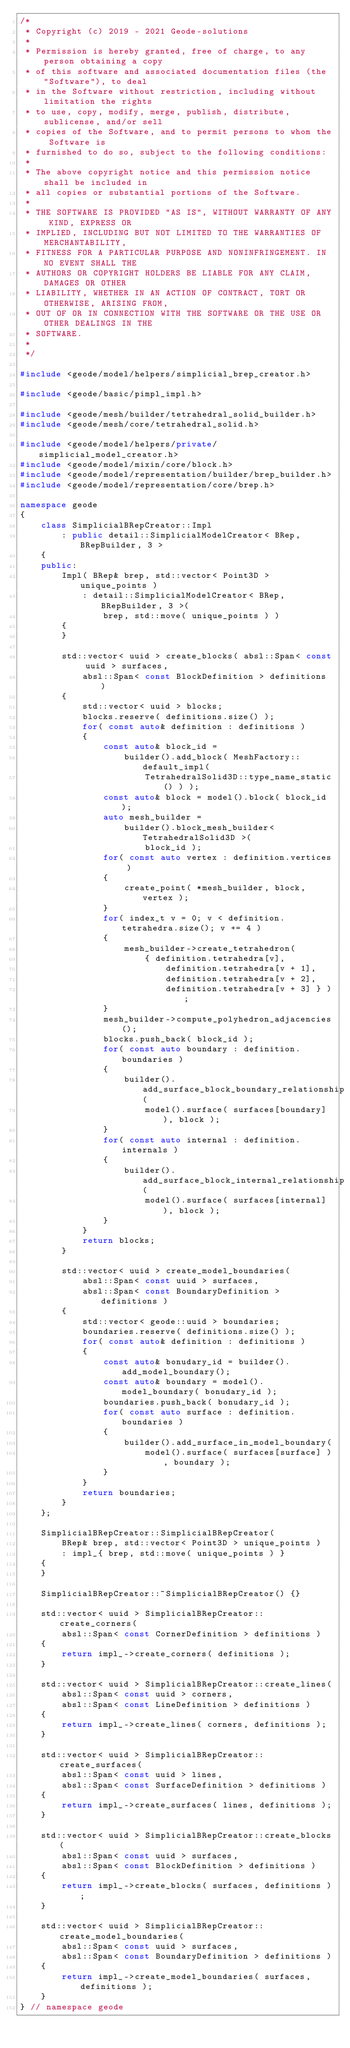<code> <loc_0><loc_0><loc_500><loc_500><_C++_>/*
 * Copyright (c) 2019 - 2021 Geode-solutions
 *
 * Permission is hereby granted, free of charge, to any person obtaining a copy
 * of this software and associated documentation files (the "Software"), to deal
 * in the Software without restriction, including without limitation the rights
 * to use, copy, modify, merge, publish, distribute, sublicense, and/or sell
 * copies of the Software, and to permit persons to whom the Software is
 * furnished to do so, subject to the following conditions:
 *
 * The above copyright notice and this permission notice shall be included in
 * all copies or substantial portions of the Software.
 *
 * THE SOFTWARE IS PROVIDED "AS IS", WITHOUT WARRANTY OF ANY KIND, EXPRESS OR
 * IMPLIED, INCLUDING BUT NOT LIMITED TO THE WARRANTIES OF MERCHANTABILITY,
 * FITNESS FOR A PARTICULAR PURPOSE AND NONINFRINGEMENT. IN NO EVENT SHALL THE
 * AUTHORS OR COPYRIGHT HOLDERS BE LIABLE FOR ANY CLAIM, DAMAGES OR OTHER
 * LIABILITY, WHETHER IN AN ACTION OF CONTRACT, TORT OR OTHERWISE, ARISING FROM,
 * OUT OF OR IN CONNECTION WITH THE SOFTWARE OR THE USE OR OTHER DEALINGS IN THE
 * SOFTWARE.
 *
 */

#include <geode/model/helpers/simplicial_brep_creator.h>

#include <geode/basic/pimpl_impl.h>

#include <geode/mesh/builder/tetrahedral_solid_builder.h>
#include <geode/mesh/core/tetrahedral_solid.h>

#include <geode/model/helpers/private/simplicial_model_creator.h>
#include <geode/model/mixin/core/block.h>
#include <geode/model/representation/builder/brep_builder.h>
#include <geode/model/representation/core/brep.h>

namespace geode
{
    class SimplicialBRepCreator::Impl
        : public detail::SimplicialModelCreator< BRep, BRepBuilder, 3 >
    {
    public:
        Impl( BRep& brep, std::vector< Point3D > unique_points )
            : detail::SimplicialModelCreator< BRep, BRepBuilder, 3 >(
                brep, std::move( unique_points ) )
        {
        }

        std::vector< uuid > create_blocks( absl::Span< const uuid > surfaces,
            absl::Span< const BlockDefinition > definitions )
        {
            std::vector< uuid > blocks;
            blocks.reserve( definitions.size() );
            for( const auto& definition : definitions )
            {
                const auto& block_id =
                    builder().add_block( MeshFactory::default_impl(
                        TetrahedralSolid3D::type_name_static() ) );
                const auto& block = model().block( block_id );
                auto mesh_builder =
                    builder().block_mesh_builder< TetrahedralSolid3D >(
                        block_id );
                for( const auto vertex : definition.vertices )
                {
                    create_point( *mesh_builder, block, vertex );
                }
                for( index_t v = 0; v < definition.tetrahedra.size(); v += 4 )
                {
                    mesh_builder->create_tetrahedron(
                        { definition.tetrahedra[v],
                            definition.tetrahedra[v + 1],
                            definition.tetrahedra[v + 2],
                            definition.tetrahedra[v + 3] } );
                }
                mesh_builder->compute_polyhedron_adjacencies();
                blocks.push_back( block_id );
                for( const auto boundary : definition.boundaries )
                {
                    builder().add_surface_block_boundary_relationship(
                        model().surface( surfaces[boundary] ), block );
                }
                for( const auto internal : definition.internals )
                {
                    builder().add_surface_block_internal_relationship(
                        model().surface( surfaces[internal] ), block );
                }
            }
            return blocks;
        }

        std::vector< uuid > create_model_boundaries(
            absl::Span< const uuid > surfaces,
            absl::Span< const BoundaryDefinition > definitions )
        {
            std::vector< geode::uuid > boundaries;
            boundaries.reserve( definitions.size() );
            for( const auto& definition : definitions )
            {
                const auto& bonudary_id = builder().add_model_boundary();
                const auto& boundary = model().model_boundary( bonudary_id );
                boundaries.push_back( bonudary_id );
                for( const auto surface : definition.boundaries )
                {
                    builder().add_surface_in_model_boundary(
                        model().surface( surfaces[surface] ), boundary );
                }
            }
            return boundaries;
        }
    };

    SimplicialBRepCreator::SimplicialBRepCreator(
        BRep& brep, std::vector< Point3D > unique_points )
        : impl_{ brep, std::move( unique_points ) }
    {
    }

    SimplicialBRepCreator::~SimplicialBRepCreator() {}

    std::vector< uuid > SimplicialBRepCreator::create_corners(
        absl::Span< const CornerDefinition > definitions )
    {
        return impl_->create_corners( definitions );
    }

    std::vector< uuid > SimplicialBRepCreator::create_lines(
        absl::Span< const uuid > corners,
        absl::Span< const LineDefinition > definitions )
    {
        return impl_->create_lines( corners, definitions );
    }

    std::vector< uuid > SimplicialBRepCreator::create_surfaces(
        absl::Span< const uuid > lines,
        absl::Span< const SurfaceDefinition > definitions )
    {
        return impl_->create_surfaces( lines, definitions );
    }

    std::vector< uuid > SimplicialBRepCreator::create_blocks(
        absl::Span< const uuid > surfaces,
        absl::Span< const BlockDefinition > definitions )
    {
        return impl_->create_blocks( surfaces, definitions );
    }

    std::vector< uuid > SimplicialBRepCreator::create_model_boundaries(
        absl::Span< const uuid > surfaces,
        absl::Span< const BoundaryDefinition > definitions )
    {
        return impl_->create_model_boundaries( surfaces, definitions );
    }
} // namespace geode</code> 